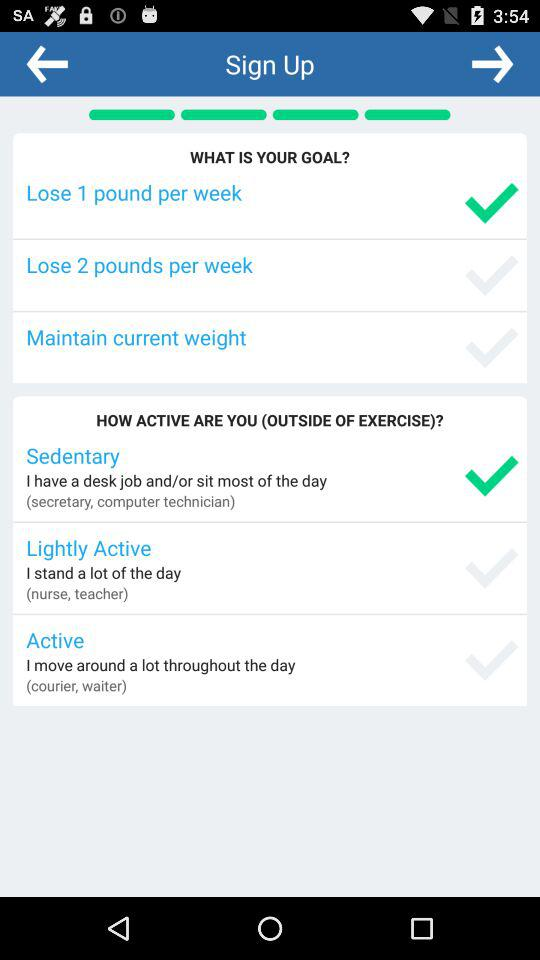Which goal is selected? The selected goal is to "Lose 1 pound per week". 